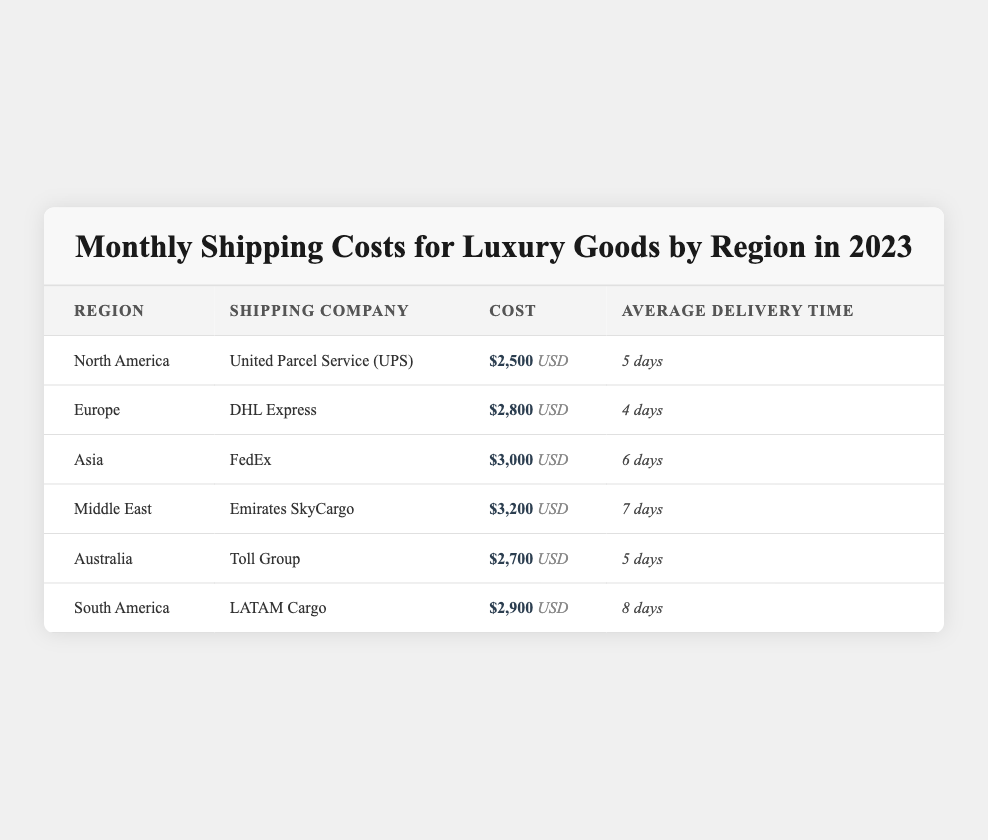What is the shipping cost for luxury goods to North America? The table lists the cost for North America as $2,500 USD.
Answer: $2,500 Which shipping company is responsible for deliveries in Europe? According to the table, DHL Express is the shipping company for Europe.
Answer: DHL Express What is the average delivery time for shipments to Asia? The table indicates that the average delivery time for Asia is 6 days.
Answer: 6 days Which region has the highest shipping cost and what is that cost? The Middle East has the highest shipping cost at $3,200 USD.
Answer: $3,200 Calculate the total shipping cost for all regions combined. Adding up all the costs: $2,500 + $2,800 + $3,000 + $3,200 + $2,700 + $2,900 gives a total of $17,100 USD.
Answer: $17,100 Is the shipping cost to Australia lower than the cost to South America? The cost for Australia is $2,700 USD, while the cost for South America is $2,900 USD. Therefore, Australia’s shipping cost is lower.
Answer: Yes What is the average delivery time for shipping to all regions? The delivery times are 5, 4, 6, 7, 5, and 8 days. The average is calculated as (5 + 4 + 6 + 7 + 5 + 8) / 6 = 5.833, which rounds to approximately 6 days.
Answer: Approximately 6 days Which region has the shortest average delivery time and what is that time? Europe has the shortest average delivery time at 4 days.
Answer: 4 days If I need the fastest delivery option, which region should I choose? The fastest average delivery time is for Europe at 4 days. Therefore, Europe should be chosen.
Answer: Europe Is it true that Asia has a higher shipping cost than North America? Yes, Asia's shipping cost of $3,000 USD is higher than North America's cost of $2,500 USD.
Answer: Yes 